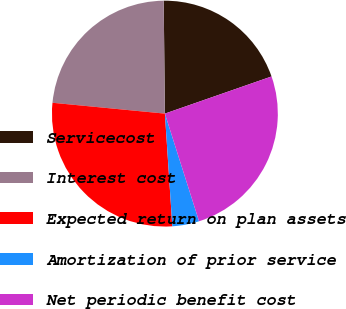<chart> <loc_0><loc_0><loc_500><loc_500><pie_chart><fcel>Servicecost<fcel>Interest cost<fcel>Expected return on plan assets<fcel>Amortization of prior service<fcel>Net periodic benefit cost<nl><fcel>19.83%<fcel>23.3%<fcel>27.58%<fcel>3.84%<fcel>25.44%<nl></chart> 